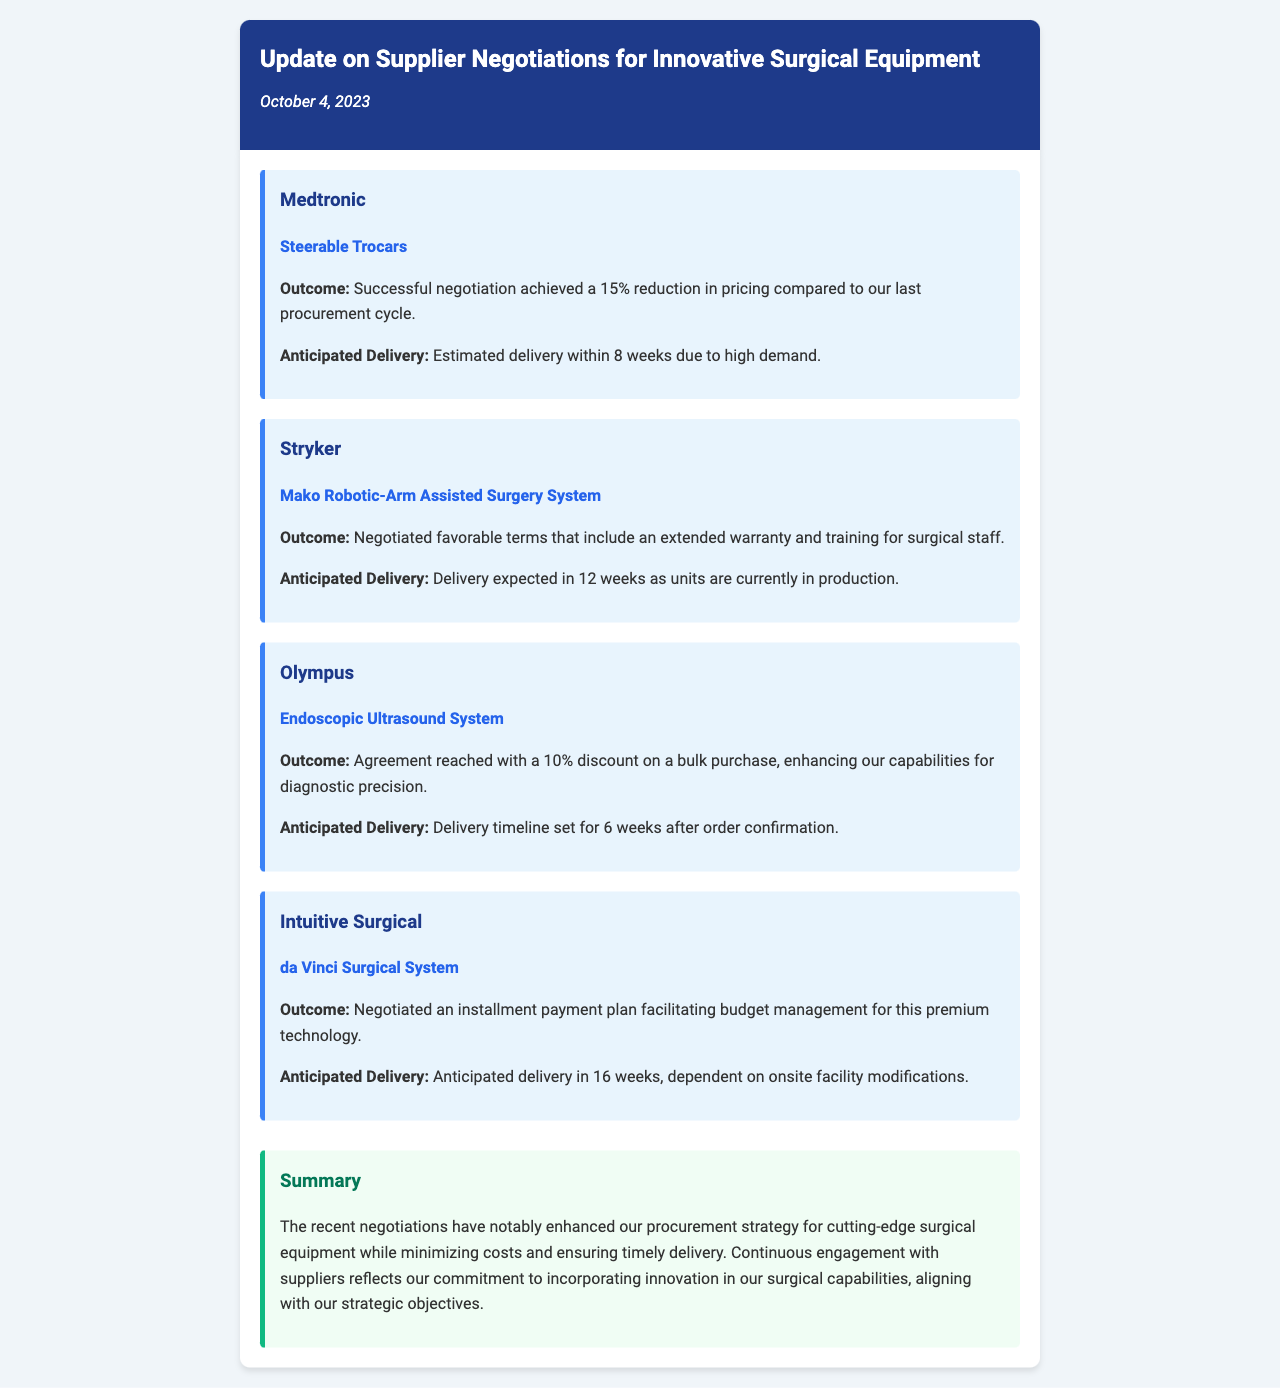What is the date of the update? The date is specified at the top of the document, which states October 4, 2023.
Answer: October 4, 2023 What surgical equipment is associated with Medtronic? The document lists the specific equipment related to each supplier, for Medtronic it is the Steerable Trocars.
Answer: Steerable Trocars What percentage reduction in pricing was achieved with Medtronic? The successful negotiation outcome for Medtronic included a 15% reduction in pricing.
Answer: 15% What is the anticipated delivery time for the Olympus equipment? The document states that the delivery timeline for Olympus is set for 6 weeks after order confirmation.
Answer: 6 weeks What unique agreement was reached with Intuitive Surgical? Intuitive Surgical included a negotiated installment payment plan to facilitate budget management.
Answer: Installment payment plan Which supplier provides the Mako Robotic-Arm Assisted Surgery System? The supplier for this equipment is specifically mentioned in the document as Stryker.
Answer: Stryker How many weeks is the anticipated delivery for the da Vinci Surgical System? The anticipated delivery time mentioned for the da Vinci Surgical System is 16 weeks.
Answer: 16 weeks What discount percentage was agreed upon for the Olympus equipment? The agreement with Olympus included a 10% discount on a bulk purchase.
Answer: 10% What is the focus of the summary in the document? The summary emphasizes enhancements in procurement strategy, cost minimization, and timely delivery of surgical equipment.
Answer: Procurement strategy 